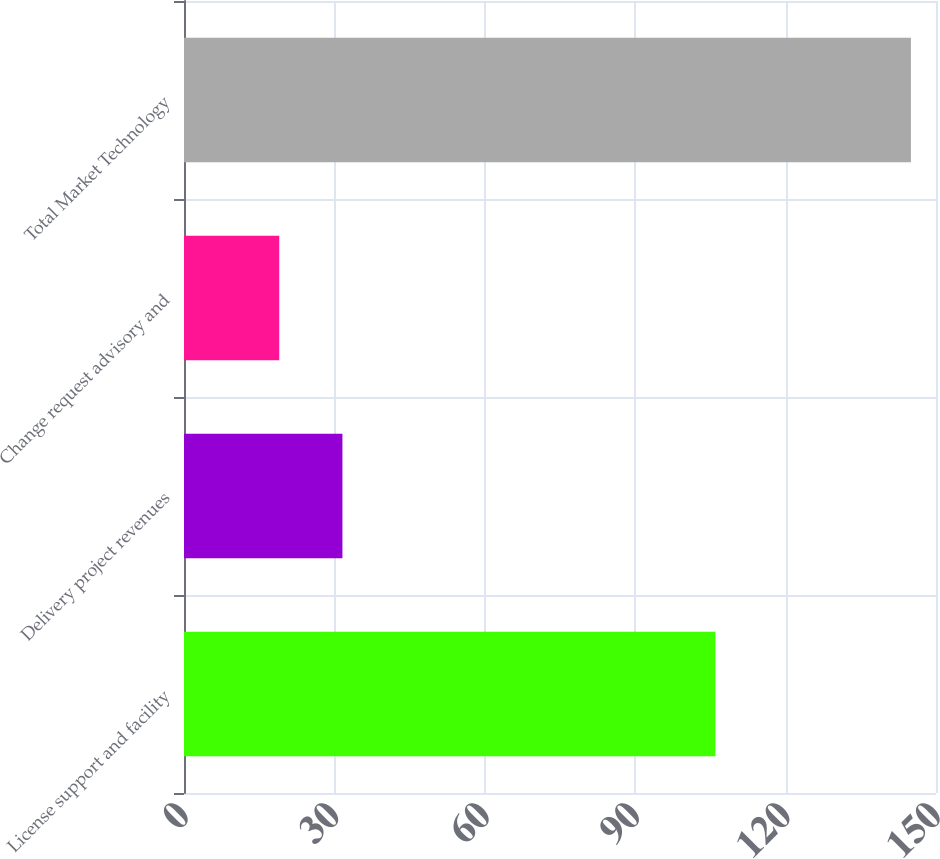Convert chart. <chart><loc_0><loc_0><loc_500><loc_500><bar_chart><fcel>License support and facility<fcel>Delivery project revenues<fcel>Change request advisory and<fcel>Total Market Technology<nl><fcel>106<fcel>31.6<fcel>19<fcel>145<nl></chart> 